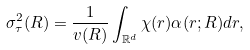Convert formula to latex. <formula><loc_0><loc_0><loc_500><loc_500>\sigma _ { \tau } ^ { 2 } ( R ) = \frac { 1 } { v ( R ) } \int _ { \mathbb { R } ^ { d } } \chi ( r ) \alpha ( r ; R ) d r ,</formula> 